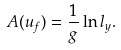Convert formula to latex. <formula><loc_0><loc_0><loc_500><loc_500>A ( u _ { f } ) = \frac { 1 } { g } \ln { l _ { y } } .</formula> 